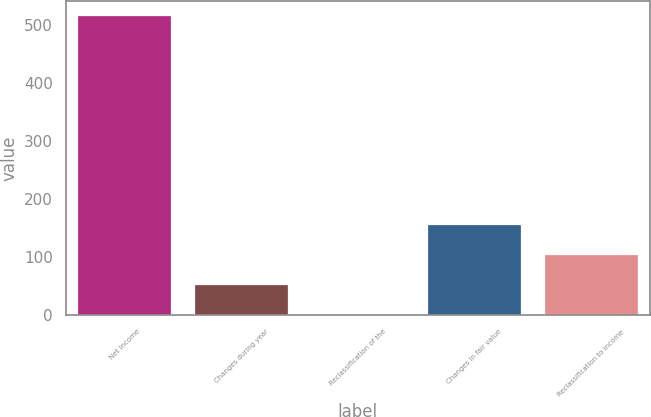Convert chart to OTSL. <chart><loc_0><loc_0><loc_500><loc_500><bar_chart><fcel>Net income<fcel>Changes during year<fcel>Reclassification of the<fcel>Changes in fair value<fcel>Reclassification to income<nl><fcel>516<fcel>52.5<fcel>1<fcel>155.5<fcel>104<nl></chart> 